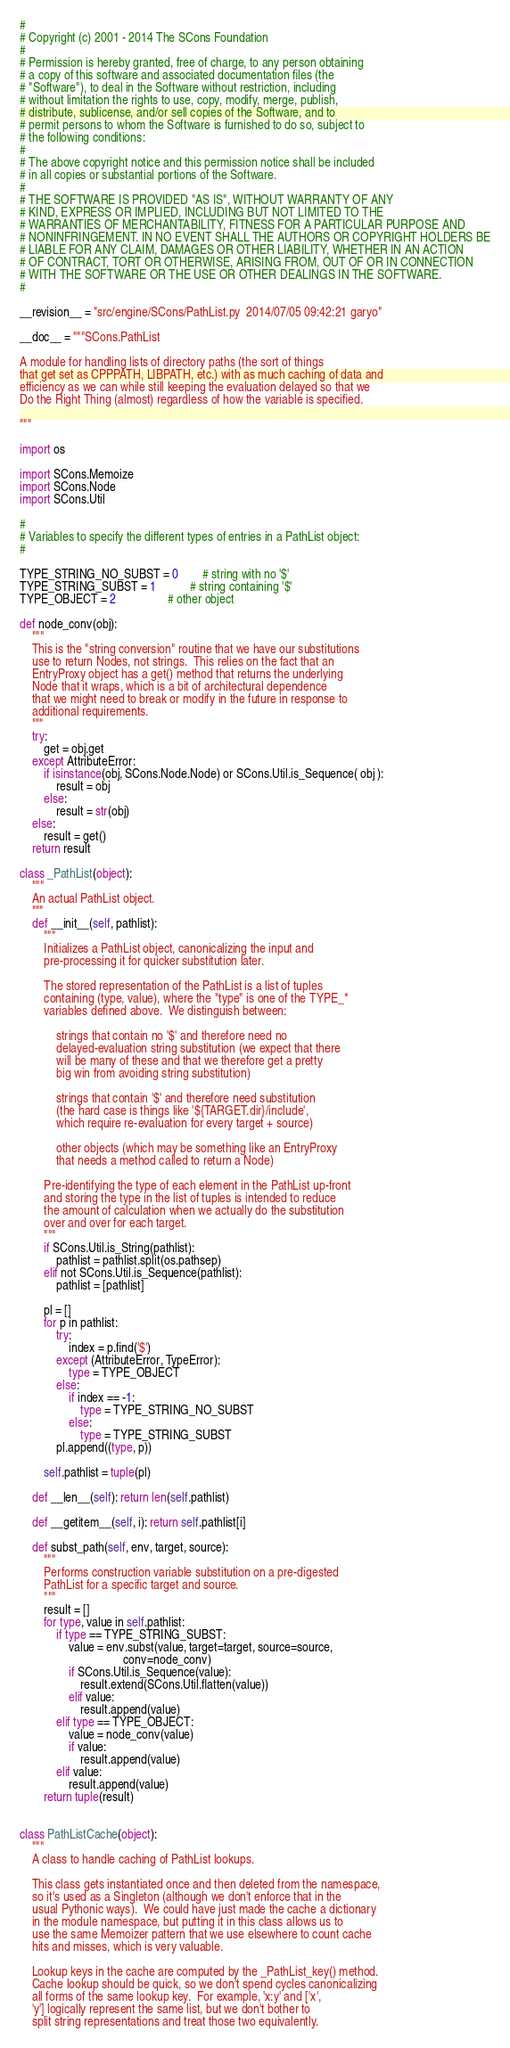Convert code to text. <code><loc_0><loc_0><loc_500><loc_500><_Python_>#
# Copyright (c) 2001 - 2014 The SCons Foundation
#
# Permission is hereby granted, free of charge, to any person obtaining
# a copy of this software and associated documentation files (the
# "Software"), to deal in the Software without restriction, including
# without limitation the rights to use, copy, modify, merge, publish,
# distribute, sublicense, and/or sell copies of the Software, and to
# permit persons to whom the Software is furnished to do so, subject to
# the following conditions:
#
# The above copyright notice and this permission notice shall be included
# in all copies or substantial portions of the Software.
#
# THE SOFTWARE IS PROVIDED "AS IS", WITHOUT WARRANTY OF ANY
# KIND, EXPRESS OR IMPLIED, INCLUDING BUT NOT LIMITED TO THE
# WARRANTIES OF MERCHANTABILITY, FITNESS FOR A PARTICULAR PURPOSE AND
# NONINFRINGEMENT. IN NO EVENT SHALL THE AUTHORS OR COPYRIGHT HOLDERS BE
# LIABLE FOR ANY CLAIM, DAMAGES OR OTHER LIABILITY, WHETHER IN AN ACTION
# OF CONTRACT, TORT OR OTHERWISE, ARISING FROM, OUT OF OR IN CONNECTION
# WITH THE SOFTWARE OR THE USE OR OTHER DEALINGS IN THE SOFTWARE.
#

__revision__ = "src/engine/SCons/PathList.py  2014/07/05 09:42:21 garyo"

__doc__ = """SCons.PathList

A module for handling lists of directory paths (the sort of things
that get set as CPPPATH, LIBPATH, etc.) with as much caching of data and
efficiency as we can while still keeping the evaluation delayed so that we
Do the Right Thing (almost) regardless of how the variable is specified.

"""

import os

import SCons.Memoize
import SCons.Node
import SCons.Util

#
# Variables to specify the different types of entries in a PathList object:
#

TYPE_STRING_NO_SUBST = 0        # string with no '$'
TYPE_STRING_SUBST = 1           # string containing '$'
TYPE_OBJECT = 2                 # other object

def node_conv(obj):
    """
    This is the "string conversion" routine that we have our substitutions
    use to return Nodes, not strings.  This relies on the fact that an
    EntryProxy object has a get() method that returns the underlying
    Node that it wraps, which is a bit of architectural dependence
    that we might need to break or modify in the future in response to
    additional requirements.
    """
    try:
        get = obj.get
    except AttributeError:
        if isinstance(obj, SCons.Node.Node) or SCons.Util.is_Sequence( obj ):
            result = obj
        else:
            result = str(obj)
    else:
        result = get()
    return result

class _PathList(object):
    """
    An actual PathList object.
    """
    def __init__(self, pathlist):
        """
        Initializes a PathList object, canonicalizing the input and
        pre-processing it for quicker substitution later.

        The stored representation of the PathList is a list of tuples
        containing (type, value), where the "type" is one of the TYPE_*
        variables defined above.  We distinguish between:

            strings that contain no '$' and therefore need no
            delayed-evaluation string substitution (we expect that there
            will be many of these and that we therefore get a pretty
            big win from avoiding string substitution)

            strings that contain '$' and therefore need substitution
            (the hard case is things like '${TARGET.dir}/include',
            which require re-evaluation for every target + source)

            other objects (which may be something like an EntryProxy
            that needs a method called to return a Node)

        Pre-identifying the type of each element in the PathList up-front
        and storing the type in the list of tuples is intended to reduce
        the amount of calculation when we actually do the substitution
        over and over for each target.
        """
        if SCons.Util.is_String(pathlist):
            pathlist = pathlist.split(os.pathsep)
        elif not SCons.Util.is_Sequence(pathlist):
            pathlist = [pathlist]

        pl = []
        for p in pathlist:
            try:
                index = p.find('$')
            except (AttributeError, TypeError):
                type = TYPE_OBJECT
            else:
                if index == -1:
                    type = TYPE_STRING_NO_SUBST
                else:
                    type = TYPE_STRING_SUBST
            pl.append((type, p))

        self.pathlist = tuple(pl)

    def __len__(self): return len(self.pathlist)

    def __getitem__(self, i): return self.pathlist[i]

    def subst_path(self, env, target, source):
        """
        Performs construction variable substitution on a pre-digested
        PathList for a specific target and source.
        """
        result = []
        for type, value in self.pathlist:
            if type == TYPE_STRING_SUBST:
                value = env.subst(value, target=target, source=source,
                                  conv=node_conv)
                if SCons.Util.is_Sequence(value):
                    result.extend(SCons.Util.flatten(value))
                elif value:
                    result.append(value)
            elif type == TYPE_OBJECT:
                value = node_conv(value)
                if value:
                    result.append(value)
            elif value:
                result.append(value)
        return tuple(result)


class PathListCache(object):
    """
    A class to handle caching of PathList lookups.

    This class gets instantiated once and then deleted from the namespace,
    so it's used as a Singleton (although we don't enforce that in the
    usual Pythonic ways).  We could have just made the cache a dictionary
    in the module namespace, but putting it in this class allows us to
    use the same Memoizer pattern that we use elsewhere to count cache
    hits and misses, which is very valuable.

    Lookup keys in the cache are computed by the _PathList_key() method.
    Cache lookup should be quick, so we don't spend cycles canonicalizing
    all forms of the same lookup key.  For example, 'x:y' and ['x',
    'y'] logically represent the same list, but we don't bother to
    split string representations and treat those two equivalently.</code> 